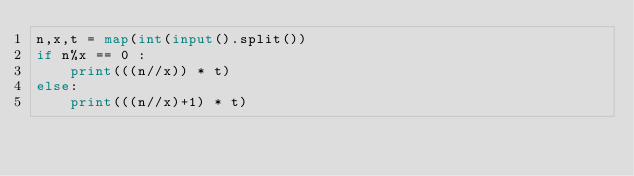Convert code to text. <code><loc_0><loc_0><loc_500><loc_500><_Python_>n,x,t = map(int(input().split())
if n%x == 0 :
    print(((n//x)) * t)
else:
    print(((n//x)+1) * t)</code> 